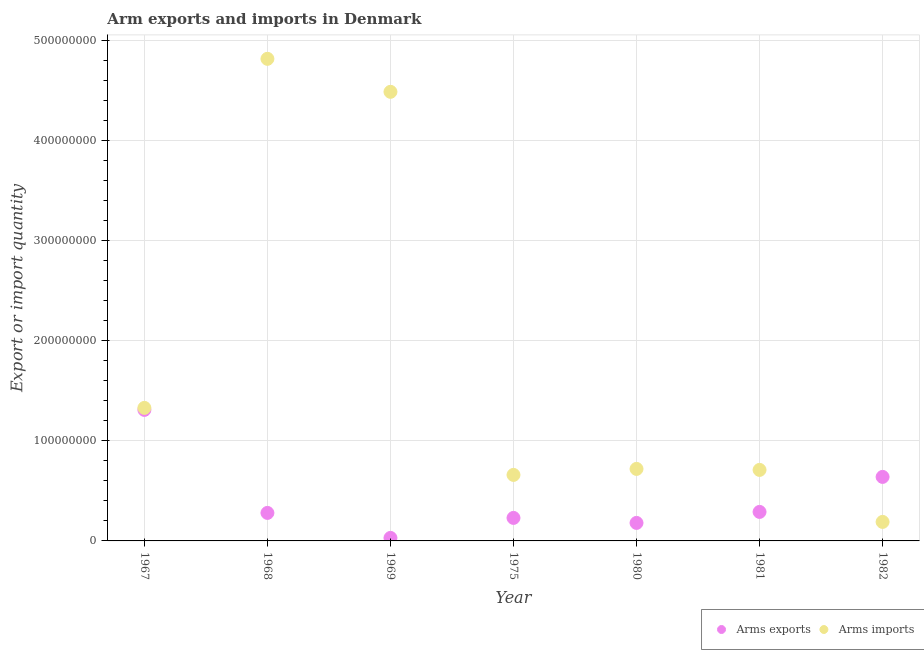How many different coloured dotlines are there?
Make the answer very short. 2. Is the number of dotlines equal to the number of legend labels?
Ensure brevity in your answer.  Yes. What is the arms exports in 1980?
Your response must be concise. 1.80e+07. Across all years, what is the maximum arms exports?
Your response must be concise. 1.31e+08. Across all years, what is the minimum arms imports?
Make the answer very short. 1.90e+07. In which year was the arms imports maximum?
Keep it short and to the point. 1968. In which year was the arms exports minimum?
Your answer should be compact. 1969. What is the total arms imports in the graph?
Your answer should be compact. 1.29e+09. What is the difference between the arms imports in 1968 and that in 1969?
Offer a terse response. 3.30e+07. What is the difference between the arms imports in 1975 and the arms exports in 1980?
Offer a very short reply. 4.80e+07. What is the average arms imports per year?
Your answer should be very brief. 1.85e+08. In the year 1981, what is the difference between the arms exports and arms imports?
Your response must be concise. -4.20e+07. What is the ratio of the arms exports in 1981 to that in 1982?
Keep it short and to the point. 0.45. Is the difference between the arms imports in 1968 and 1981 greater than the difference between the arms exports in 1968 and 1981?
Keep it short and to the point. Yes. What is the difference between the highest and the second highest arms imports?
Provide a succinct answer. 3.30e+07. What is the difference between the highest and the lowest arms imports?
Ensure brevity in your answer.  4.63e+08. In how many years, is the arms imports greater than the average arms imports taken over all years?
Provide a succinct answer. 2. Is the sum of the arms imports in 1980 and 1982 greater than the maximum arms exports across all years?
Your answer should be very brief. No. Does the arms exports monotonically increase over the years?
Offer a very short reply. No. Is the arms exports strictly greater than the arms imports over the years?
Make the answer very short. No. How many years are there in the graph?
Ensure brevity in your answer.  7. Are the values on the major ticks of Y-axis written in scientific E-notation?
Your answer should be compact. No. Does the graph contain any zero values?
Provide a short and direct response. No. How many legend labels are there?
Your answer should be very brief. 2. What is the title of the graph?
Your response must be concise. Arm exports and imports in Denmark. Does "Central government" appear as one of the legend labels in the graph?
Your answer should be very brief. No. What is the label or title of the X-axis?
Provide a short and direct response. Year. What is the label or title of the Y-axis?
Provide a short and direct response. Export or import quantity. What is the Export or import quantity of Arms exports in 1967?
Provide a short and direct response. 1.31e+08. What is the Export or import quantity of Arms imports in 1967?
Make the answer very short. 1.33e+08. What is the Export or import quantity in Arms exports in 1968?
Your answer should be very brief. 2.80e+07. What is the Export or import quantity of Arms imports in 1968?
Provide a short and direct response. 4.82e+08. What is the Export or import quantity of Arms exports in 1969?
Your answer should be very brief. 3.00e+06. What is the Export or import quantity of Arms imports in 1969?
Make the answer very short. 4.49e+08. What is the Export or import quantity of Arms exports in 1975?
Provide a short and direct response. 2.30e+07. What is the Export or import quantity of Arms imports in 1975?
Your answer should be very brief. 6.60e+07. What is the Export or import quantity in Arms exports in 1980?
Give a very brief answer. 1.80e+07. What is the Export or import quantity in Arms imports in 1980?
Keep it short and to the point. 7.20e+07. What is the Export or import quantity in Arms exports in 1981?
Provide a succinct answer. 2.90e+07. What is the Export or import quantity of Arms imports in 1981?
Ensure brevity in your answer.  7.10e+07. What is the Export or import quantity in Arms exports in 1982?
Give a very brief answer. 6.40e+07. What is the Export or import quantity in Arms imports in 1982?
Make the answer very short. 1.90e+07. Across all years, what is the maximum Export or import quantity in Arms exports?
Keep it short and to the point. 1.31e+08. Across all years, what is the maximum Export or import quantity of Arms imports?
Give a very brief answer. 4.82e+08. Across all years, what is the minimum Export or import quantity in Arms imports?
Your answer should be very brief. 1.90e+07. What is the total Export or import quantity in Arms exports in the graph?
Offer a terse response. 2.96e+08. What is the total Export or import quantity in Arms imports in the graph?
Offer a very short reply. 1.29e+09. What is the difference between the Export or import quantity of Arms exports in 1967 and that in 1968?
Give a very brief answer. 1.03e+08. What is the difference between the Export or import quantity of Arms imports in 1967 and that in 1968?
Keep it short and to the point. -3.49e+08. What is the difference between the Export or import quantity of Arms exports in 1967 and that in 1969?
Your response must be concise. 1.28e+08. What is the difference between the Export or import quantity in Arms imports in 1967 and that in 1969?
Provide a succinct answer. -3.16e+08. What is the difference between the Export or import quantity of Arms exports in 1967 and that in 1975?
Give a very brief answer. 1.08e+08. What is the difference between the Export or import quantity of Arms imports in 1967 and that in 1975?
Your response must be concise. 6.70e+07. What is the difference between the Export or import quantity in Arms exports in 1967 and that in 1980?
Your response must be concise. 1.13e+08. What is the difference between the Export or import quantity in Arms imports in 1967 and that in 1980?
Provide a short and direct response. 6.10e+07. What is the difference between the Export or import quantity in Arms exports in 1967 and that in 1981?
Make the answer very short. 1.02e+08. What is the difference between the Export or import quantity of Arms imports in 1967 and that in 1981?
Your answer should be compact. 6.20e+07. What is the difference between the Export or import quantity in Arms exports in 1967 and that in 1982?
Ensure brevity in your answer.  6.70e+07. What is the difference between the Export or import quantity in Arms imports in 1967 and that in 1982?
Offer a very short reply. 1.14e+08. What is the difference between the Export or import quantity in Arms exports in 1968 and that in 1969?
Make the answer very short. 2.50e+07. What is the difference between the Export or import quantity of Arms imports in 1968 and that in 1969?
Make the answer very short. 3.30e+07. What is the difference between the Export or import quantity of Arms exports in 1968 and that in 1975?
Offer a terse response. 5.00e+06. What is the difference between the Export or import quantity of Arms imports in 1968 and that in 1975?
Make the answer very short. 4.16e+08. What is the difference between the Export or import quantity of Arms imports in 1968 and that in 1980?
Offer a terse response. 4.10e+08. What is the difference between the Export or import quantity of Arms imports in 1968 and that in 1981?
Your answer should be compact. 4.11e+08. What is the difference between the Export or import quantity of Arms exports in 1968 and that in 1982?
Keep it short and to the point. -3.60e+07. What is the difference between the Export or import quantity of Arms imports in 1968 and that in 1982?
Provide a succinct answer. 4.63e+08. What is the difference between the Export or import quantity of Arms exports in 1969 and that in 1975?
Provide a succinct answer. -2.00e+07. What is the difference between the Export or import quantity in Arms imports in 1969 and that in 1975?
Provide a short and direct response. 3.83e+08. What is the difference between the Export or import quantity in Arms exports in 1969 and that in 1980?
Make the answer very short. -1.50e+07. What is the difference between the Export or import quantity of Arms imports in 1969 and that in 1980?
Offer a terse response. 3.77e+08. What is the difference between the Export or import quantity in Arms exports in 1969 and that in 1981?
Provide a short and direct response. -2.60e+07. What is the difference between the Export or import quantity in Arms imports in 1969 and that in 1981?
Offer a very short reply. 3.78e+08. What is the difference between the Export or import quantity of Arms exports in 1969 and that in 1982?
Provide a succinct answer. -6.10e+07. What is the difference between the Export or import quantity of Arms imports in 1969 and that in 1982?
Ensure brevity in your answer.  4.30e+08. What is the difference between the Export or import quantity of Arms exports in 1975 and that in 1980?
Make the answer very short. 5.00e+06. What is the difference between the Export or import quantity in Arms imports in 1975 and that in 1980?
Offer a terse response. -6.00e+06. What is the difference between the Export or import quantity of Arms exports in 1975 and that in 1981?
Give a very brief answer. -6.00e+06. What is the difference between the Export or import quantity of Arms imports in 1975 and that in 1981?
Offer a very short reply. -5.00e+06. What is the difference between the Export or import quantity in Arms exports in 1975 and that in 1982?
Give a very brief answer. -4.10e+07. What is the difference between the Export or import quantity in Arms imports in 1975 and that in 1982?
Your answer should be very brief. 4.70e+07. What is the difference between the Export or import quantity of Arms exports in 1980 and that in 1981?
Offer a very short reply. -1.10e+07. What is the difference between the Export or import quantity in Arms imports in 1980 and that in 1981?
Your answer should be very brief. 1.00e+06. What is the difference between the Export or import quantity of Arms exports in 1980 and that in 1982?
Provide a short and direct response. -4.60e+07. What is the difference between the Export or import quantity of Arms imports in 1980 and that in 1982?
Keep it short and to the point. 5.30e+07. What is the difference between the Export or import quantity of Arms exports in 1981 and that in 1982?
Your answer should be very brief. -3.50e+07. What is the difference between the Export or import quantity of Arms imports in 1981 and that in 1982?
Your answer should be compact. 5.20e+07. What is the difference between the Export or import quantity of Arms exports in 1967 and the Export or import quantity of Arms imports in 1968?
Your answer should be very brief. -3.51e+08. What is the difference between the Export or import quantity of Arms exports in 1967 and the Export or import quantity of Arms imports in 1969?
Give a very brief answer. -3.18e+08. What is the difference between the Export or import quantity in Arms exports in 1967 and the Export or import quantity in Arms imports in 1975?
Your response must be concise. 6.50e+07. What is the difference between the Export or import quantity of Arms exports in 1967 and the Export or import quantity of Arms imports in 1980?
Provide a short and direct response. 5.90e+07. What is the difference between the Export or import quantity of Arms exports in 1967 and the Export or import quantity of Arms imports in 1981?
Your answer should be very brief. 6.00e+07. What is the difference between the Export or import quantity in Arms exports in 1967 and the Export or import quantity in Arms imports in 1982?
Ensure brevity in your answer.  1.12e+08. What is the difference between the Export or import quantity of Arms exports in 1968 and the Export or import quantity of Arms imports in 1969?
Your response must be concise. -4.21e+08. What is the difference between the Export or import quantity in Arms exports in 1968 and the Export or import quantity in Arms imports in 1975?
Your answer should be compact. -3.80e+07. What is the difference between the Export or import quantity of Arms exports in 1968 and the Export or import quantity of Arms imports in 1980?
Ensure brevity in your answer.  -4.40e+07. What is the difference between the Export or import quantity in Arms exports in 1968 and the Export or import quantity in Arms imports in 1981?
Your answer should be very brief. -4.30e+07. What is the difference between the Export or import quantity of Arms exports in 1968 and the Export or import quantity of Arms imports in 1982?
Keep it short and to the point. 9.00e+06. What is the difference between the Export or import quantity of Arms exports in 1969 and the Export or import quantity of Arms imports in 1975?
Make the answer very short. -6.30e+07. What is the difference between the Export or import quantity in Arms exports in 1969 and the Export or import quantity in Arms imports in 1980?
Provide a succinct answer. -6.90e+07. What is the difference between the Export or import quantity in Arms exports in 1969 and the Export or import quantity in Arms imports in 1981?
Provide a short and direct response. -6.80e+07. What is the difference between the Export or import quantity in Arms exports in 1969 and the Export or import quantity in Arms imports in 1982?
Your answer should be very brief. -1.60e+07. What is the difference between the Export or import quantity in Arms exports in 1975 and the Export or import quantity in Arms imports in 1980?
Offer a terse response. -4.90e+07. What is the difference between the Export or import quantity in Arms exports in 1975 and the Export or import quantity in Arms imports in 1981?
Provide a succinct answer. -4.80e+07. What is the difference between the Export or import quantity in Arms exports in 1980 and the Export or import quantity in Arms imports in 1981?
Your response must be concise. -5.30e+07. What is the difference between the Export or import quantity in Arms exports in 1980 and the Export or import quantity in Arms imports in 1982?
Your response must be concise. -1.00e+06. What is the difference between the Export or import quantity in Arms exports in 1981 and the Export or import quantity in Arms imports in 1982?
Offer a very short reply. 1.00e+07. What is the average Export or import quantity of Arms exports per year?
Your answer should be compact. 4.23e+07. What is the average Export or import quantity in Arms imports per year?
Give a very brief answer. 1.85e+08. In the year 1968, what is the difference between the Export or import quantity in Arms exports and Export or import quantity in Arms imports?
Your answer should be compact. -4.54e+08. In the year 1969, what is the difference between the Export or import quantity of Arms exports and Export or import quantity of Arms imports?
Your response must be concise. -4.46e+08. In the year 1975, what is the difference between the Export or import quantity of Arms exports and Export or import quantity of Arms imports?
Provide a short and direct response. -4.30e+07. In the year 1980, what is the difference between the Export or import quantity of Arms exports and Export or import quantity of Arms imports?
Your answer should be very brief. -5.40e+07. In the year 1981, what is the difference between the Export or import quantity in Arms exports and Export or import quantity in Arms imports?
Your response must be concise. -4.20e+07. In the year 1982, what is the difference between the Export or import quantity of Arms exports and Export or import quantity of Arms imports?
Ensure brevity in your answer.  4.50e+07. What is the ratio of the Export or import quantity in Arms exports in 1967 to that in 1968?
Your response must be concise. 4.68. What is the ratio of the Export or import quantity in Arms imports in 1967 to that in 1968?
Provide a succinct answer. 0.28. What is the ratio of the Export or import quantity of Arms exports in 1967 to that in 1969?
Keep it short and to the point. 43.67. What is the ratio of the Export or import quantity of Arms imports in 1967 to that in 1969?
Keep it short and to the point. 0.3. What is the ratio of the Export or import quantity in Arms exports in 1967 to that in 1975?
Give a very brief answer. 5.7. What is the ratio of the Export or import quantity of Arms imports in 1967 to that in 1975?
Offer a very short reply. 2.02. What is the ratio of the Export or import quantity in Arms exports in 1967 to that in 1980?
Offer a very short reply. 7.28. What is the ratio of the Export or import quantity in Arms imports in 1967 to that in 1980?
Your response must be concise. 1.85. What is the ratio of the Export or import quantity in Arms exports in 1967 to that in 1981?
Offer a terse response. 4.52. What is the ratio of the Export or import quantity in Arms imports in 1967 to that in 1981?
Your response must be concise. 1.87. What is the ratio of the Export or import quantity in Arms exports in 1967 to that in 1982?
Ensure brevity in your answer.  2.05. What is the ratio of the Export or import quantity in Arms imports in 1967 to that in 1982?
Your answer should be compact. 7. What is the ratio of the Export or import quantity of Arms exports in 1968 to that in 1969?
Provide a succinct answer. 9.33. What is the ratio of the Export or import quantity in Arms imports in 1968 to that in 1969?
Give a very brief answer. 1.07. What is the ratio of the Export or import quantity in Arms exports in 1968 to that in 1975?
Your answer should be compact. 1.22. What is the ratio of the Export or import quantity in Arms imports in 1968 to that in 1975?
Provide a succinct answer. 7.3. What is the ratio of the Export or import quantity of Arms exports in 1968 to that in 1980?
Your answer should be compact. 1.56. What is the ratio of the Export or import quantity in Arms imports in 1968 to that in 1980?
Your answer should be compact. 6.69. What is the ratio of the Export or import quantity of Arms exports in 1968 to that in 1981?
Provide a succinct answer. 0.97. What is the ratio of the Export or import quantity in Arms imports in 1968 to that in 1981?
Ensure brevity in your answer.  6.79. What is the ratio of the Export or import quantity in Arms exports in 1968 to that in 1982?
Offer a terse response. 0.44. What is the ratio of the Export or import quantity of Arms imports in 1968 to that in 1982?
Provide a succinct answer. 25.37. What is the ratio of the Export or import quantity in Arms exports in 1969 to that in 1975?
Your answer should be compact. 0.13. What is the ratio of the Export or import quantity in Arms imports in 1969 to that in 1975?
Make the answer very short. 6.8. What is the ratio of the Export or import quantity in Arms imports in 1969 to that in 1980?
Keep it short and to the point. 6.24. What is the ratio of the Export or import quantity of Arms exports in 1969 to that in 1981?
Your response must be concise. 0.1. What is the ratio of the Export or import quantity of Arms imports in 1969 to that in 1981?
Provide a short and direct response. 6.32. What is the ratio of the Export or import quantity in Arms exports in 1969 to that in 1982?
Give a very brief answer. 0.05. What is the ratio of the Export or import quantity in Arms imports in 1969 to that in 1982?
Provide a short and direct response. 23.63. What is the ratio of the Export or import quantity of Arms exports in 1975 to that in 1980?
Your answer should be compact. 1.28. What is the ratio of the Export or import quantity of Arms exports in 1975 to that in 1981?
Offer a very short reply. 0.79. What is the ratio of the Export or import quantity in Arms imports in 1975 to that in 1981?
Give a very brief answer. 0.93. What is the ratio of the Export or import quantity of Arms exports in 1975 to that in 1982?
Provide a short and direct response. 0.36. What is the ratio of the Export or import quantity in Arms imports in 1975 to that in 1982?
Your answer should be very brief. 3.47. What is the ratio of the Export or import quantity of Arms exports in 1980 to that in 1981?
Ensure brevity in your answer.  0.62. What is the ratio of the Export or import quantity in Arms imports in 1980 to that in 1981?
Offer a terse response. 1.01. What is the ratio of the Export or import quantity of Arms exports in 1980 to that in 1982?
Keep it short and to the point. 0.28. What is the ratio of the Export or import quantity in Arms imports in 1980 to that in 1982?
Make the answer very short. 3.79. What is the ratio of the Export or import quantity in Arms exports in 1981 to that in 1982?
Your answer should be compact. 0.45. What is the ratio of the Export or import quantity in Arms imports in 1981 to that in 1982?
Provide a succinct answer. 3.74. What is the difference between the highest and the second highest Export or import quantity in Arms exports?
Offer a very short reply. 6.70e+07. What is the difference between the highest and the second highest Export or import quantity of Arms imports?
Your answer should be very brief. 3.30e+07. What is the difference between the highest and the lowest Export or import quantity of Arms exports?
Ensure brevity in your answer.  1.28e+08. What is the difference between the highest and the lowest Export or import quantity of Arms imports?
Give a very brief answer. 4.63e+08. 